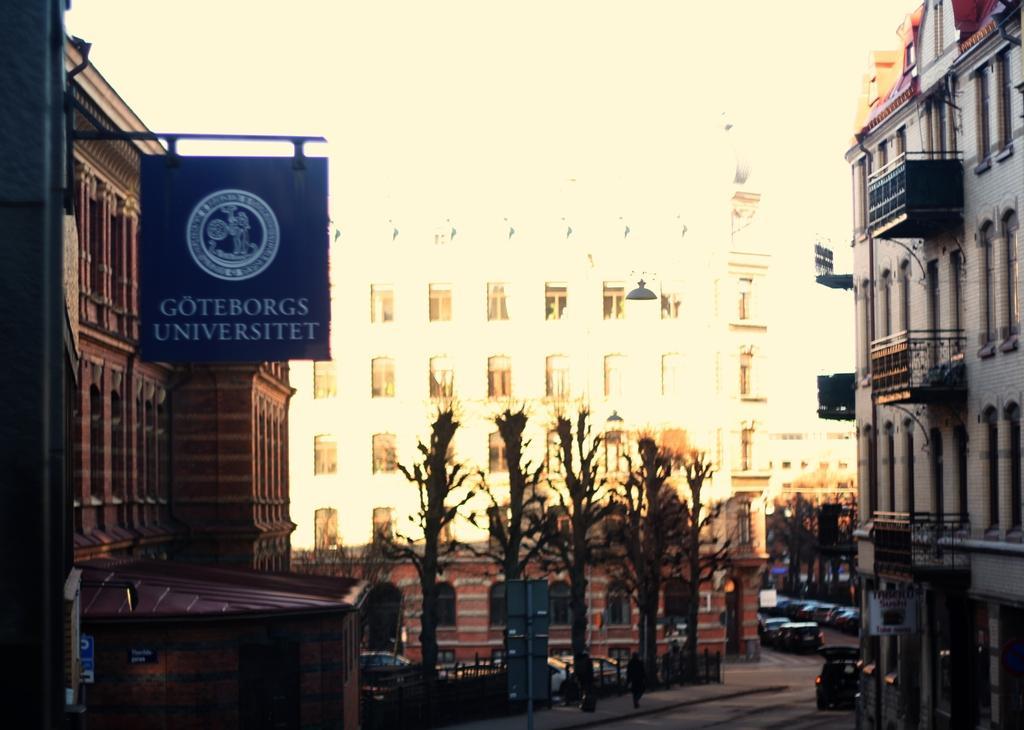How would you summarize this image in a sentence or two? In this picture I can see few trees and vehicles in the middle, on the left side there is a board. There are buildings on either side of this image. 